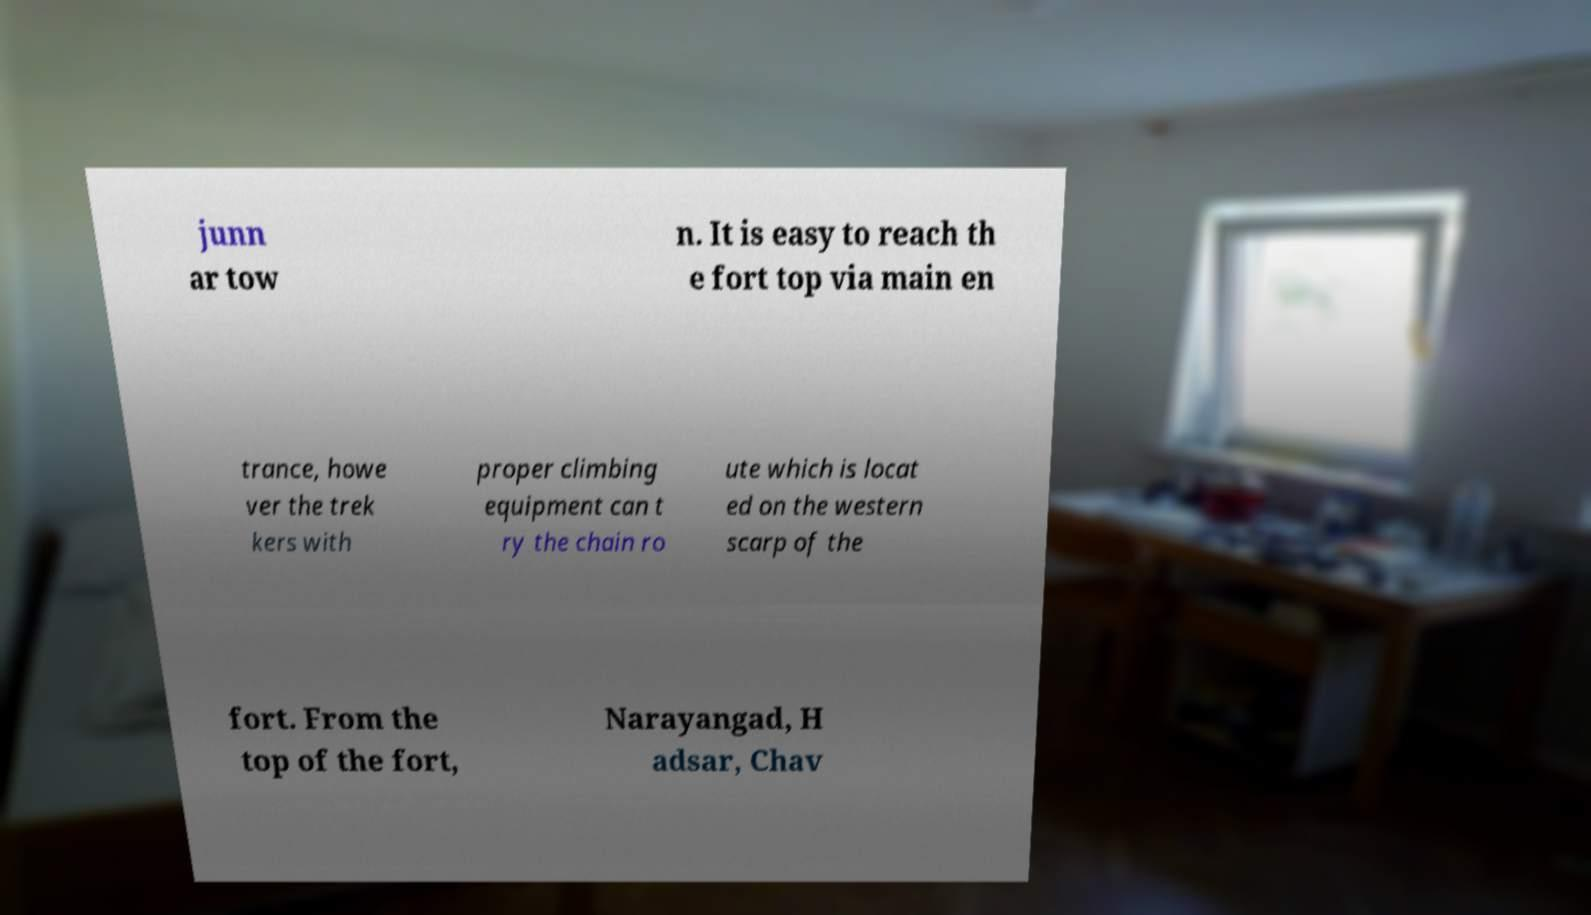What messages or text are displayed in this image? I need them in a readable, typed format. junn ar tow n. It is easy to reach th e fort top via main en trance, howe ver the trek kers with proper climbing equipment can t ry the chain ro ute which is locat ed on the western scarp of the fort. From the top of the fort, Narayangad, H adsar, Chav 